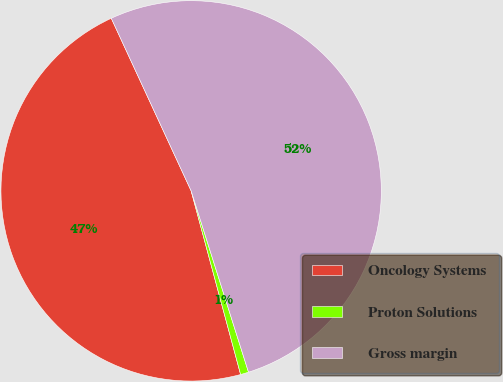Convert chart. <chart><loc_0><loc_0><loc_500><loc_500><pie_chart><fcel>Oncology Systems<fcel>Proton Solutions<fcel>Gross margin<nl><fcel>47.29%<fcel>0.69%<fcel>52.02%<nl></chart> 